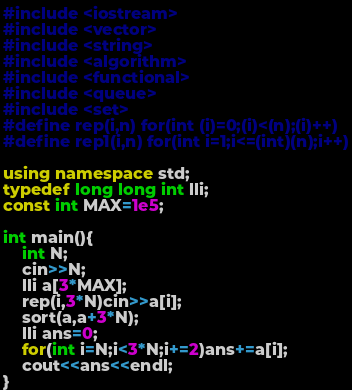Convert code to text. <code><loc_0><loc_0><loc_500><loc_500><_C++_>#include <iostream>
#include <vector>
#include <string>
#include <algorithm>
#include <functional>
#include <queue>
#include <set>
#define rep(i,n) for(int (i)=0;(i)<(n);(i)++)
#define rep1(i,n) for(int i=1;i<=(int)(n);i++)
 
using namespace std;
typedef long long int lli;
const int MAX=1e5;
 
int main(){
	int N;
	cin>>N;
	lli a[3*MAX];
	rep(i,3*N)cin>>a[i];
	sort(a,a+3*N);
	lli ans=0;
	for(int i=N;i<3*N;i+=2)ans+=a[i];
	cout<<ans<<endl;
}</code> 